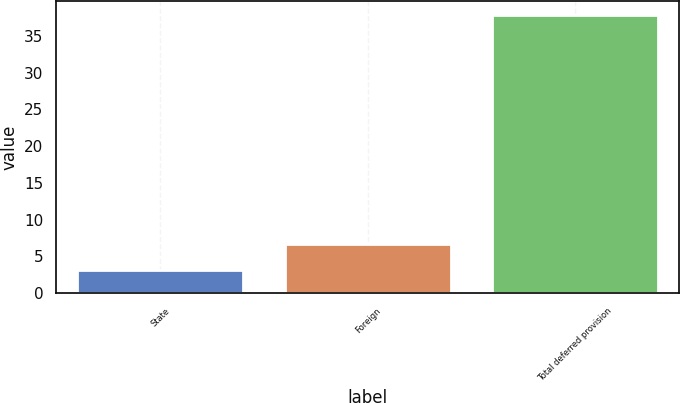Convert chart. <chart><loc_0><loc_0><loc_500><loc_500><bar_chart><fcel>State<fcel>Foreign<fcel>Total deferred provision<nl><fcel>3.2<fcel>6.66<fcel>37.8<nl></chart> 